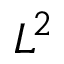<formula> <loc_0><loc_0><loc_500><loc_500>L ^ { 2 }</formula> 